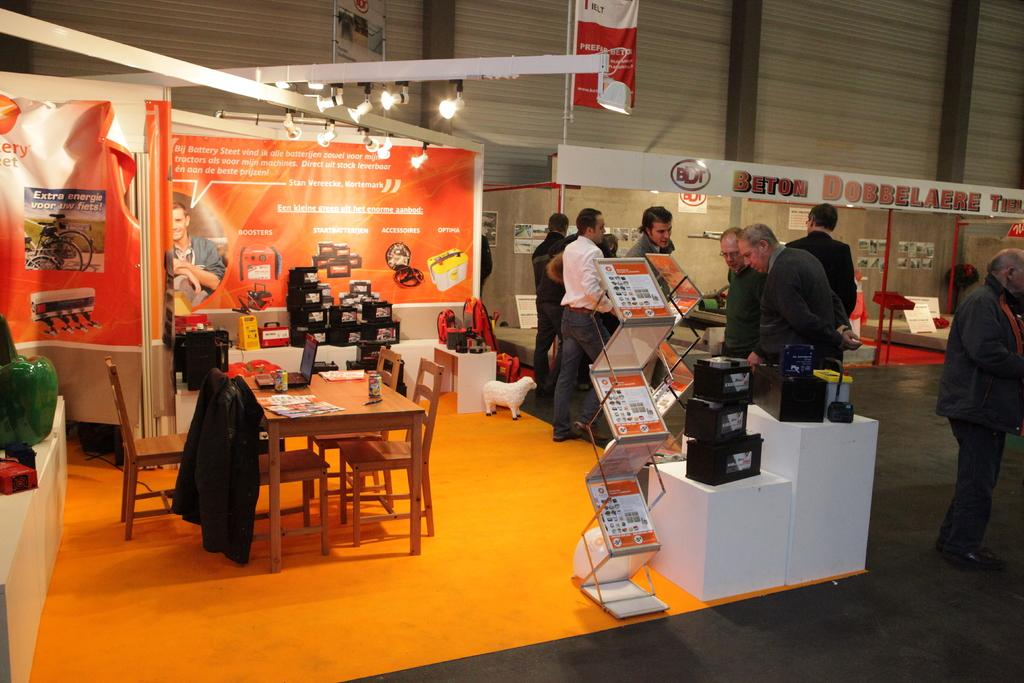What type of establishment is visible in the image? There is a store in the image. Where is the store located? The store is located in a hall. What are the people in the image doing? The people are standing and watching something. Can you see any grapes growing in the image? There are no grapes or vineyards present in the image. 